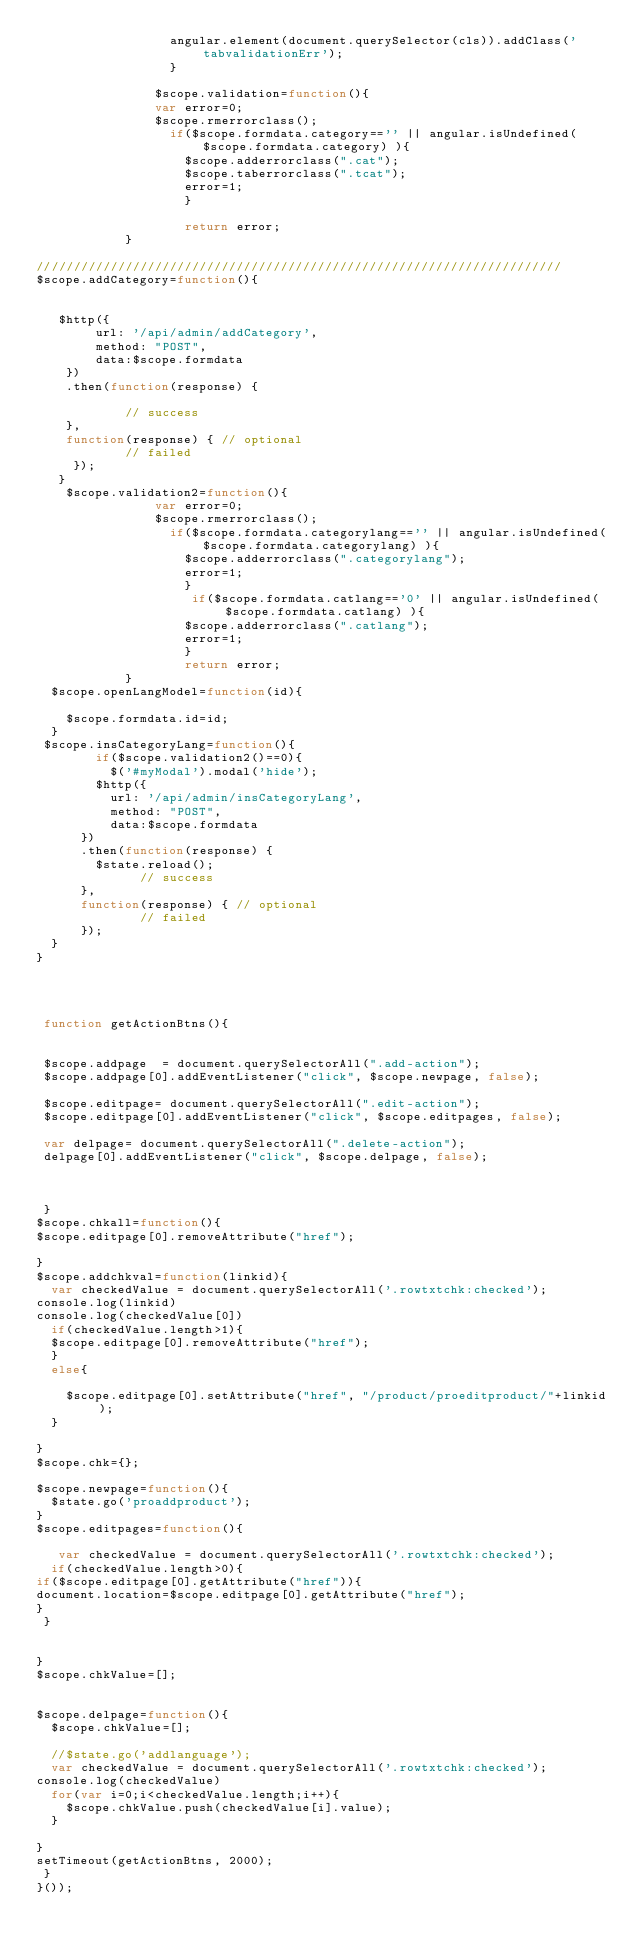Convert code to text. <code><loc_0><loc_0><loc_500><loc_500><_JavaScript_>                  angular.element(document.querySelector(cls)).addClass('tabvalidationErr');
                  }

                $scope.validation=function(){
                var error=0;
                $scope.rmerrorclass();
                  if($scope.formdata.category=='' || angular.isUndefined($scope.formdata.category) ){
                    $scope.adderrorclass(".cat");
                    $scope.taberrorclass(".tcat");
                    error=1;
                    }

                    return error;          
            }

///////////////////////////////////////////////////////////////////////
$scope.addCategory=function(){


   $http({
        url: '/api/admin/addCategory',
        method: "POST",
        data:$scope.formdata
    })
    .then(function(response) {
    
            // success
    }, 
    function(response) { // optional
            // failed
     });
   }
    $scope.validation2=function(){
                var error=0;
                $scope.rmerrorclass();
                  if($scope.formdata.categorylang=='' || angular.isUndefined($scope.formdata.categorylang) ){
                    $scope.adderrorclass(".categorylang");
                    error=1;
                    }
                     if($scope.formdata.catlang=='0' || angular.isUndefined($scope.formdata.catlang) ){
                    $scope.adderrorclass(".catlang");
                    error=1;
                    }
                    return error;          
            }
  $scope.openLangModel=function(id){
    
    $scope.formdata.id=id;
  }
 $scope.insCategoryLang=function(){
        if($scope.validation2()==0){
          $('#myModal').modal('hide');
        $http({
          url: '/api/admin/insCategoryLang',
          method: "POST",
          data:$scope.formdata
      })
      .then(function(response) {
        $state.reload();
              // success
      }, 
      function(response) { // optional
              // failed
      });
  }
}




 function getActionBtns(){


 $scope.addpage  = document.querySelectorAll(".add-action");
 $scope.addpage[0].addEventListener("click", $scope.newpage, false);

 $scope.editpage= document.querySelectorAll(".edit-action");
 $scope.editpage[0].addEventListener("click", $scope.editpages, false);

 var delpage= document.querySelectorAll(".delete-action");
 delpage[0].addEventListener("click", $scope.delpage, false);



 }
$scope.chkall=function(){
$scope.editpage[0].removeAttribute("href");
 
}
$scope.addchkval=function(linkid){
  var checkedValue = document.querySelectorAll('.rowtxtchk:checked');
console.log(linkid)
console.log(checkedValue[0])
  if(checkedValue.length>1){
  $scope.editpage[0].removeAttribute("href");
  }
  else{

    $scope.editpage[0].setAttribute("href", "/product/proeditproduct/"+linkid);
  }

}
$scope.chk={};

$scope.newpage=function(){
  $state.go('proaddproduct');
}
$scope.editpages=function(){
  
   var checkedValue = document.querySelectorAll('.rowtxtchk:checked');
  if(checkedValue.length>0){
if($scope.editpage[0].getAttribute("href")){
document.location=$scope.editpage[0].getAttribute("href");
}
 }

 
}
$scope.chkValue=[];


$scope.delpage=function(){
  $scope.chkValue=[];
 
  //$state.go('addlanguage');
  var checkedValue = document.querySelectorAll('.rowtxtchk:checked');
console.log(checkedValue)
  for(var i=0;i<checkedValue.length;i++){
    $scope.chkValue.push(checkedValue[i].value);
  }
 
}
setTimeout(getActionBtns, 2000);
 }
}());
</code> 